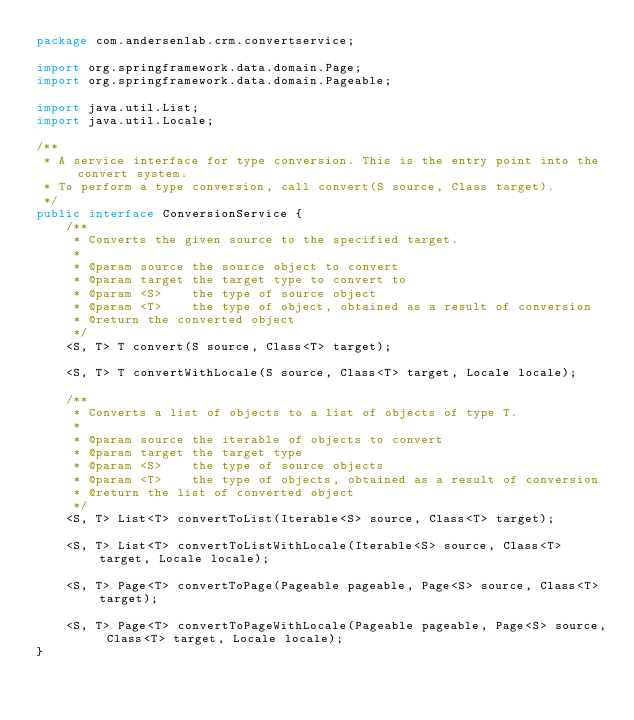<code> <loc_0><loc_0><loc_500><loc_500><_Java_>package com.andersenlab.crm.convertservice;

import org.springframework.data.domain.Page;
import org.springframework.data.domain.Pageable;

import java.util.List;
import java.util.Locale;

/**
 * A service interface for type conversion. This is the entry point into the convert system.
 * To perform a type conversion, call convert(S source, Class target).
 */
public interface ConversionService {
    /**
     * Converts the given source to the specified target.
     *
     * @param source the source object to convert
     * @param target the target type to convert to
     * @param <S>    the type of source object
     * @param <T>    the type of object, obtained as a result of conversion
     * @return the converted object
     */
    <S, T> T convert(S source, Class<T> target);

    <S, T> T convertWithLocale(S source, Class<T> target, Locale locale);

    /**
     * Converts a list of objects to a list of objects of type T.
     *
     * @param source the iterable of objects to convert
     * @param target the target type
     * @param <S>    the type of source objects
     * @param <T>    the type of objects, obtained as a result of conversion
     * @return the list of converted object
     */
    <S, T> List<T> convertToList(Iterable<S> source, Class<T> target);

    <S, T> List<T> convertToListWithLocale(Iterable<S> source, Class<T> target, Locale locale);

    <S, T> Page<T> convertToPage(Pageable pageable, Page<S> source, Class<T> target);

    <S, T> Page<T> convertToPageWithLocale(Pageable pageable, Page<S> source, Class<T> target, Locale locale);
}
</code> 